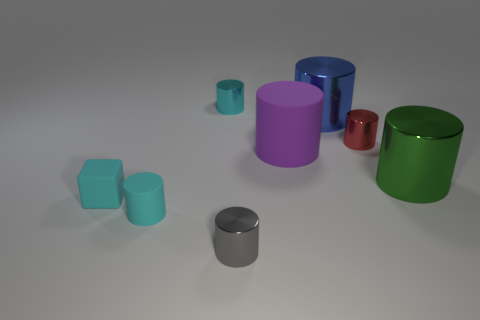Subtract all green metallic cylinders. How many cylinders are left? 6 Add 1 small cyan rubber cubes. How many objects exist? 9 Subtract all green cylinders. How many cylinders are left? 6 Subtract all cylinders. How many objects are left? 1 Subtract 5 cylinders. How many cylinders are left? 2 Subtract all brown cylinders. Subtract all purple blocks. How many cylinders are left? 7 Subtract all red cubes. How many blue cylinders are left? 1 Subtract all green shiny objects. Subtract all tiny rubber cylinders. How many objects are left? 6 Add 7 tiny gray cylinders. How many tiny gray cylinders are left? 8 Add 7 tiny yellow metal balls. How many tiny yellow metal balls exist? 7 